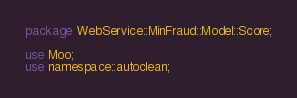<code> <loc_0><loc_0><loc_500><loc_500><_Perl_>package WebService::MinFraud::Model::Score;

use Moo;
use namespace::autoclean;
</code> 